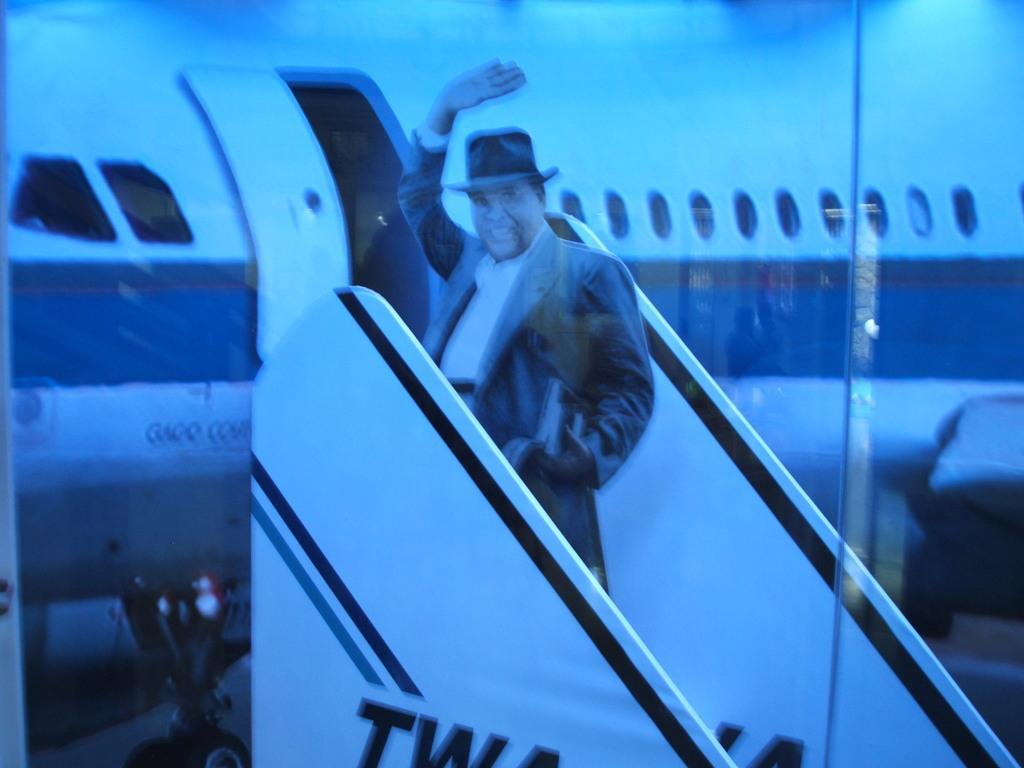In one or two sentences, can you explain what this image depicts? This image consists of a man is standing on the stairs of a fight. In the background, there is a plane in white color. 